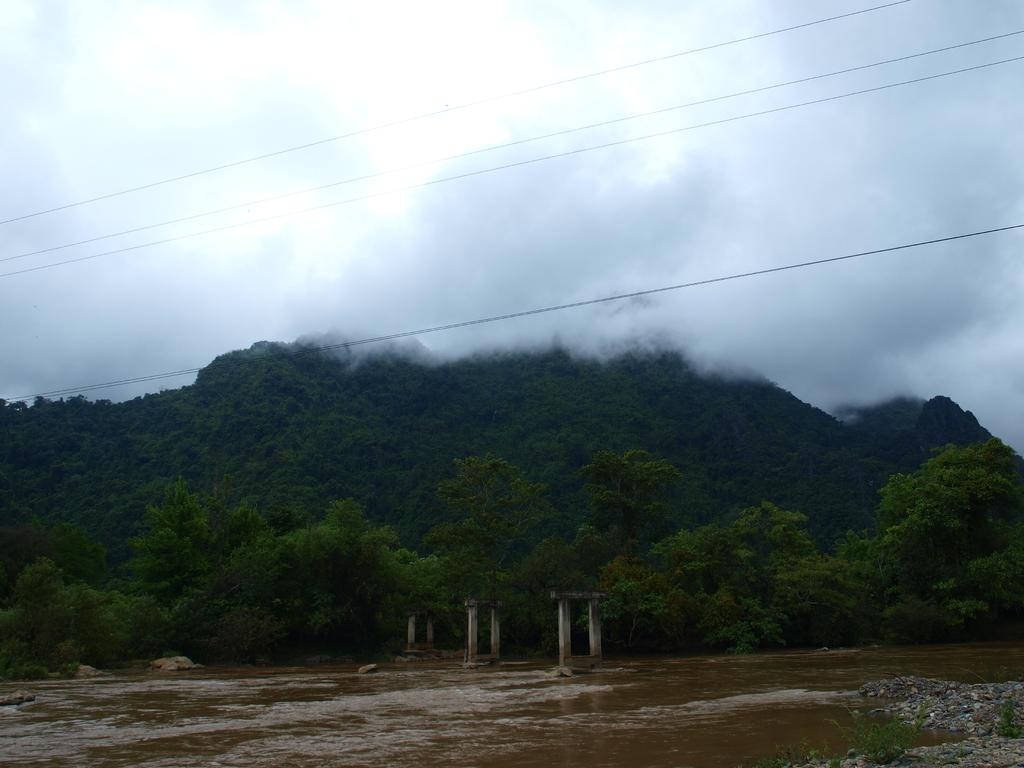What type of natural landscape is depicted in the image? The image contains hills, trees, water, plants, and stones, which are elements of a natural landscape. Are there any man-made structures visible in the image? Yes, there are concrete structures in the image. What is the weather like in the image? The image shows clouds and fog, which suggests a potentially overcast or misty day. What type of wires can be seen in the image? The image contains wires, but the specific type is not mentioned. How many geese are swimming in the water in the image? There are no geese visible in the image; it contains hills, trees, concrete structures, water, plants, stones, clouds, fog, and wires. What time of year does the visitor in the image seem to be enjoying? There is no visitor present in the image, so it is not possible to determine the time of year they might be enjoying. 